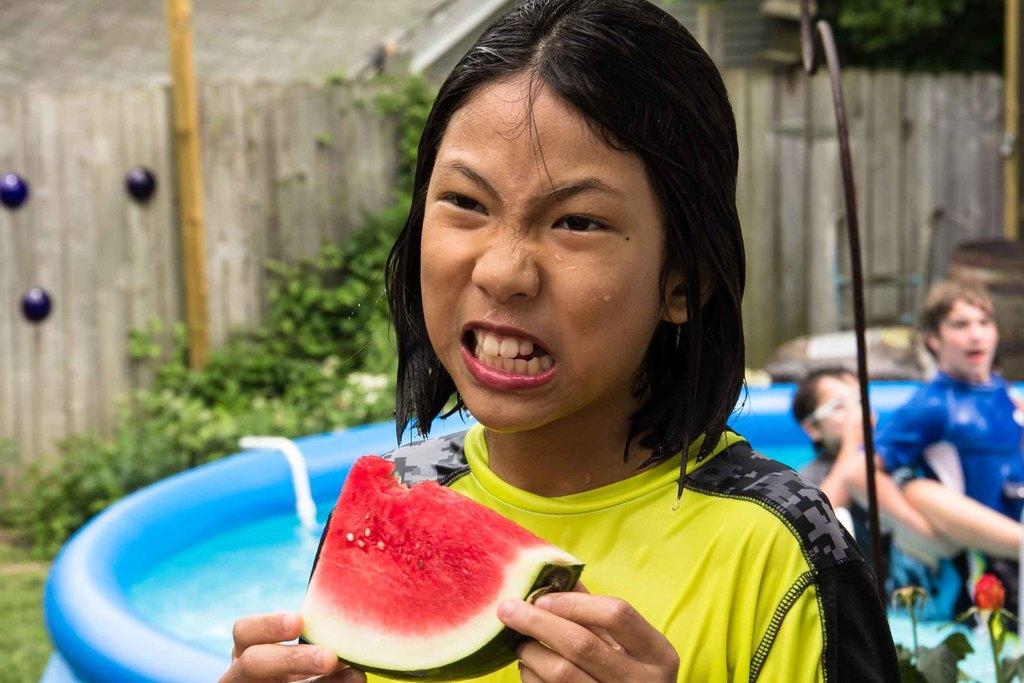Can you describe this image briefly? In this image we can see a boy. He is wearing a T-shirt and holding watermelon in his hand. In the background, we can see plants, wooden fence, inflatable object, people, plants, metal object and a house. 